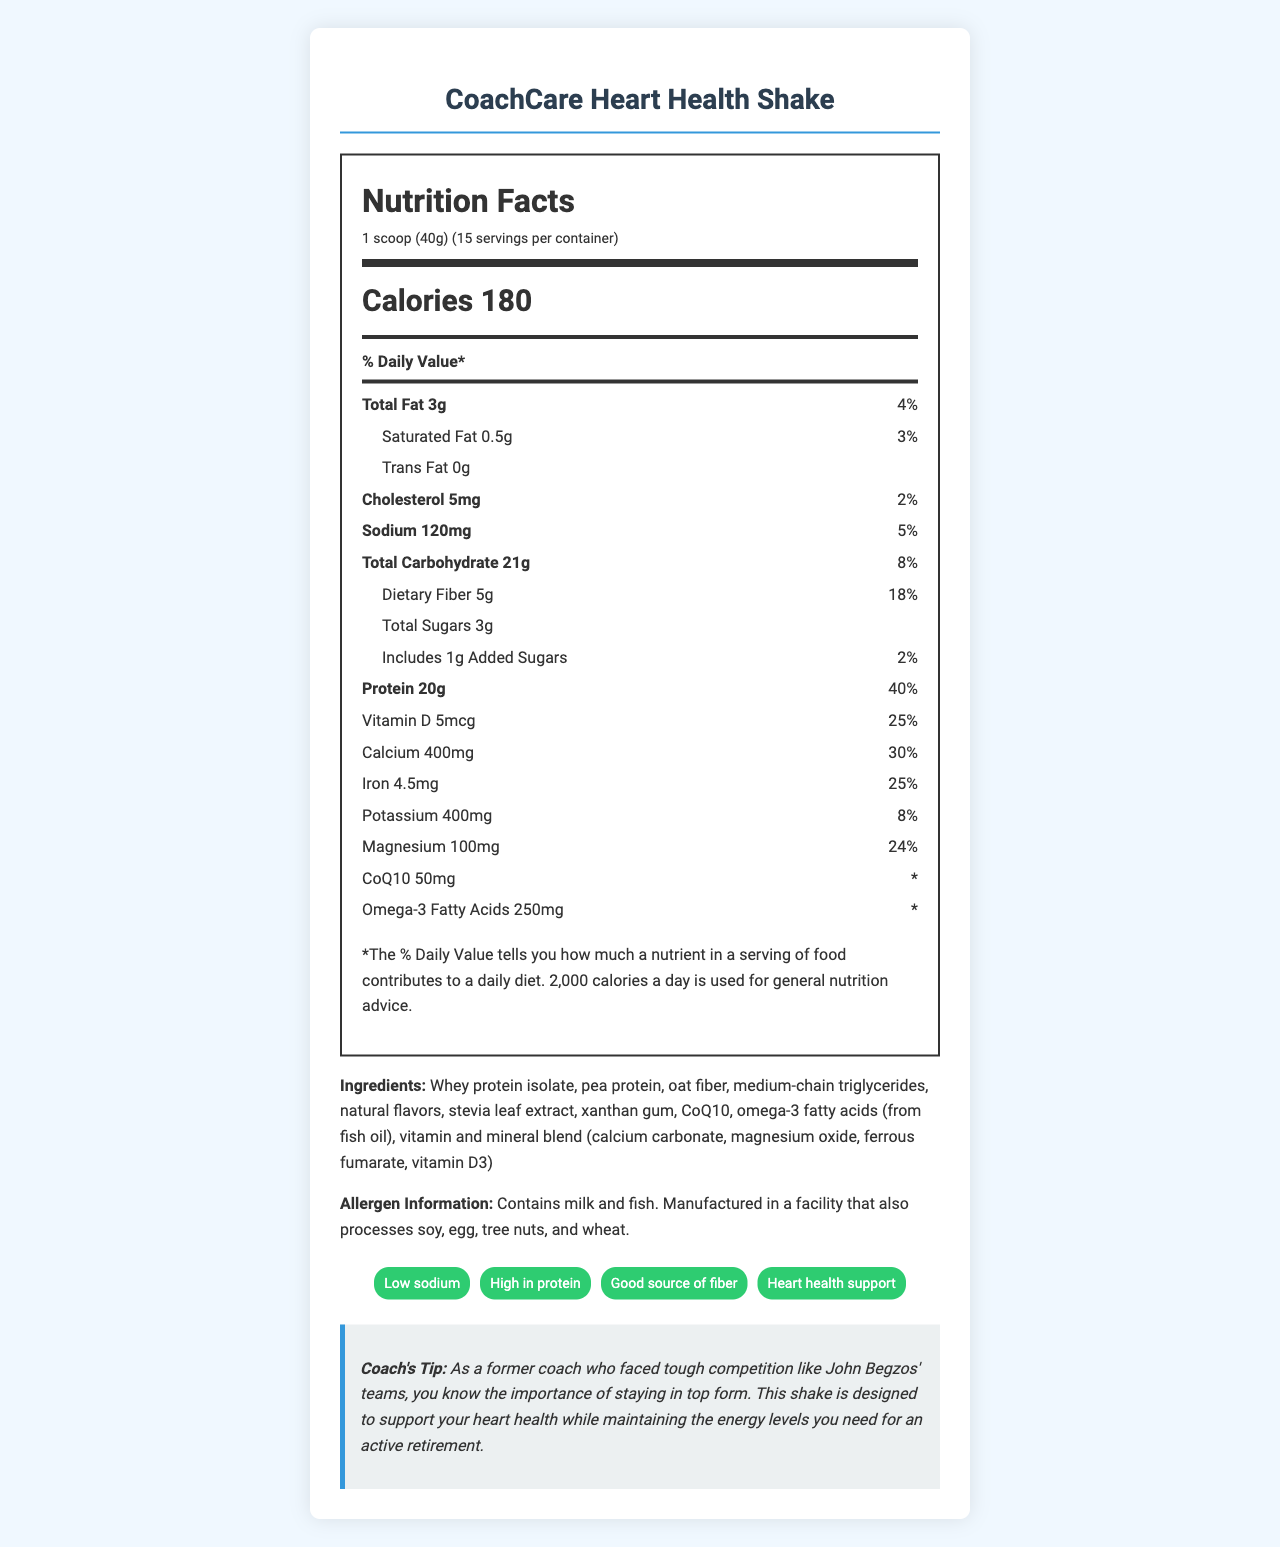what is the serving size for the CoachCare Heart Health Shake? The serving size is clearly indicated in the nutrition facts section as "1 scoop (40g)".
Answer: 1 scoop (40g) how many calories are in one serving of the shake? The number of calories is given in the main info section as "Calories 180".
Answer: 180 what percentage of the daily calcium value does one serving provide? The document states under the nutrient row for calcium that one serving provides 30% of the daily value.
Answer: 30% does the CoachCare Heart Health Shake contain trans fat? The document explicitly states "Trans Fat 0g" in the nutritional details.
Answer: No what are the main ingredients listed for this shake? The document lists the ingredients clearly in the ingredients section.
Answer: Whey protein isolate, pea protein, oat fiber, medium-chain triglycerides, natural flavors, stevia leaf extract, xanthan gum, CoQ10, omega-3 fatty acids (from fish oil), vitamin and mineral blend (calcium carbonate, magnesium oxide, ferrous fumarate, vitamin D3) what is the daily value percentage for dietary fiber? A. 8% B. 5% C. 18% D. 24% In the nutrient info section for dietary fiber, the daily value is indicated as 18%.
Answer: C. 18% which of the following is not listed in the claim statements for the shake? A. Low sodium B. High in protein C. Gluten-free D. Good source of fiber The claim statements listed in the document do not include "Gluten-free".
Answer: C. Gluten-free does the shake contain any allergens? The allergen information states that the product contains milk and fish.
Answer: Yes does the CoachCare Heart Health Shake support heart health? The coach's tip and claim statements explicitly mention that this shake supports heart health.
Answer: Yes summarize the main idea of the CoachCare Heart Health Shake nutrition facts. The document provides detailed nutrition facts, ingredient list, and health claims emphasizing the product’s benefits for heart health, especially for former coaches.
Answer: The CoachCare Heart Health Shake is a low-sodium meal replacement designed for heart health. It offers 180 calories per serving, with key nutrients including 20g of protein, 120mg of sodium, 5g of fiber, as well as vitamins and minerals like calcium, iron, and magnesium. This shake is high in protein and fiber, contains low fat, and includes beneficial components like CoQ10 and omega-3 fatty acids. what is the source of omega-3 fatty acids in the shake? The ingredients list indicates that omega-3 fatty acids are derived from fish oil.
Answer: Fish oil what is the daily value percentage of total carbohydrates per serving? The percentage daily value for total carbohydrates is listed as 8% in the document.
Answer: 8% how many servings come in one container of the shake? The document states that there are 15 servings per container in the serving info section.
Answer: 15 how much cholesterol does one serving of the shake contain? The nutrient information details that one serving contains 5mg of cholesterol.
Answer: 5mg what kind of protein sources are used in the shake? The ingredients list specifies whey protein isolate and pea protein as sources of protein.
Answer: Whey protein isolate, pea protein identify one nutrient that does not have its daily value percentage listed. The document does not list a daily value percentage for CoQ10; it only provides the amount (50mg).
Answer: CoQ10 what other allergenic ingredients might be processed in the facility where the shake is manufactured? The allergen information section indicates that the facility also processes soy, egg, tree nuts, and wheat.
Answer: Soy, egg, tree nuts, and wheat are there any added sugars in the shake? The nutritional information specifies that there is 1g of added sugars per serving.
Answer: Yes how much protein does one serving of the shake provide? The protein content per serving is indicated as 20g in the nutrient information section.
Answer: 20g based on the visual information in the document, how much CoQ10 is in the shake? The nutrients section lists the amount of CoQ10 as 50mg.
Answer: 50mg does the CoachCare Heart Health Shake contain vitamin B12? The document does not provide any information about the presence or absence of vitamin B12.
Answer: Cannot be determined 